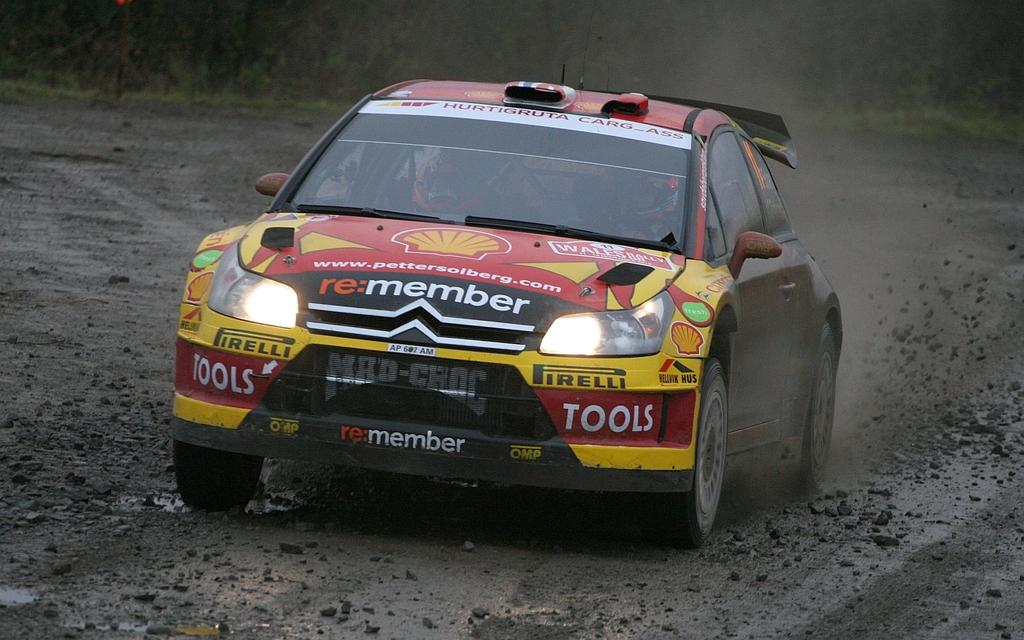What is the main subject in the center of the image? There is a car in the center of the image. What type of surface is visible at the bottom of the image? There is ground visible at the bottom of the image. Can you see any glass objects in the image? There is no mention of any glass objects in the provided facts, so we cannot determine if any are present in the image. 